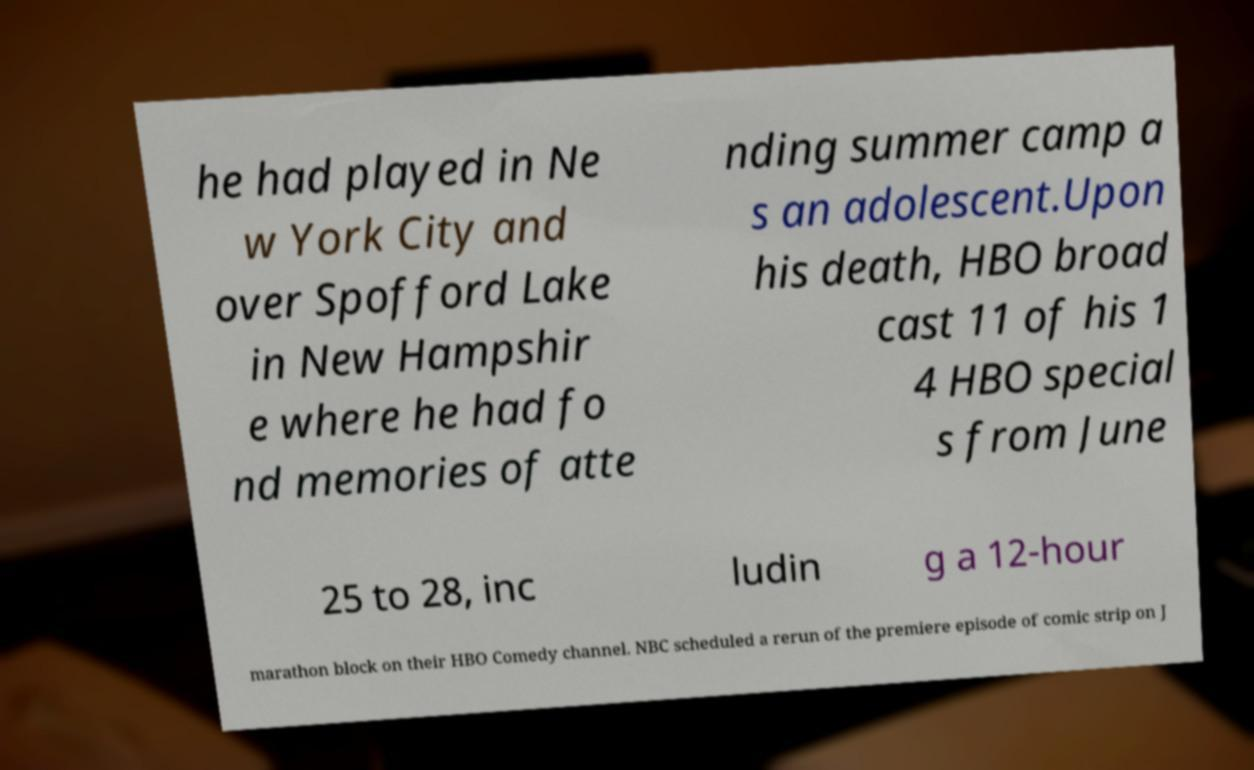Please read and relay the text visible in this image. What does it say? he had played in Ne w York City and over Spofford Lake in New Hampshir e where he had fo nd memories of atte nding summer camp a s an adolescent.Upon his death, HBO broad cast 11 of his 1 4 HBO special s from June 25 to 28, inc ludin g a 12-hour marathon block on their HBO Comedy channel. NBC scheduled a rerun of the premiere episode of comic strip on J 